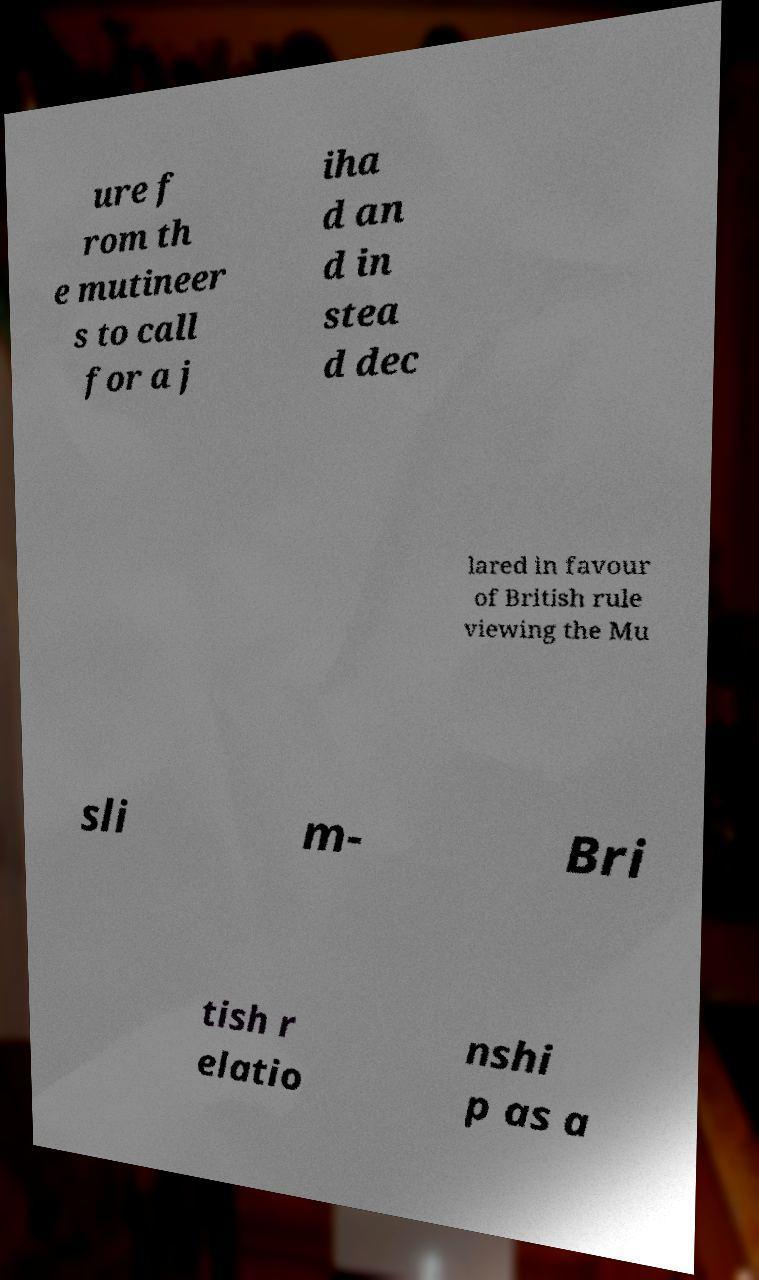I need the written content from this picture converted into text. Can you do that? ure f rom th e mutineer s to call for a j iha d an d in stea d dec lared in favour of British rule viewing the Mu sli m- Bri tish r elatio nshi p as a 